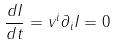Convert formula to latex. <formula><loc_0><loc_0><loc_500><loc_500>\frac { d I } { d t } = v ^ { i } \partial _ { i } I = 0</formula> 